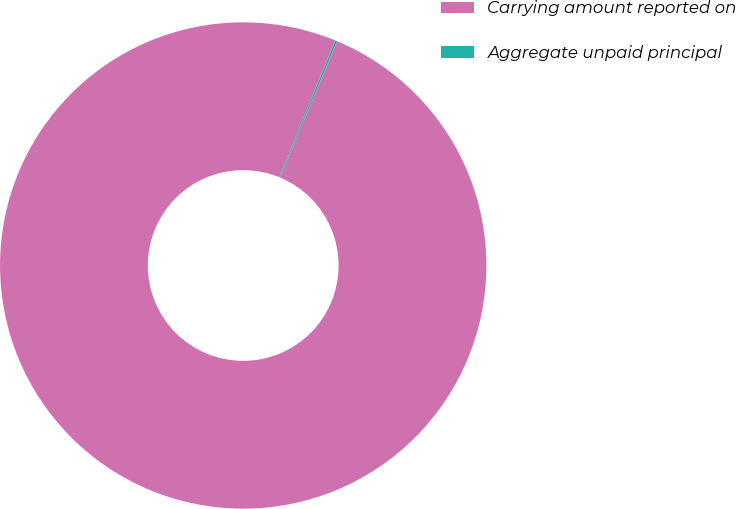Convert chart to OTSL. <chart><loc_0><loc_0><loc_500><loc_500><pie_chart><fcel>Carrying amount reported on<fcel>Aggregate unpaid principal<nl><fcel>99.87%<fcel>0.13%<nl></chart> 